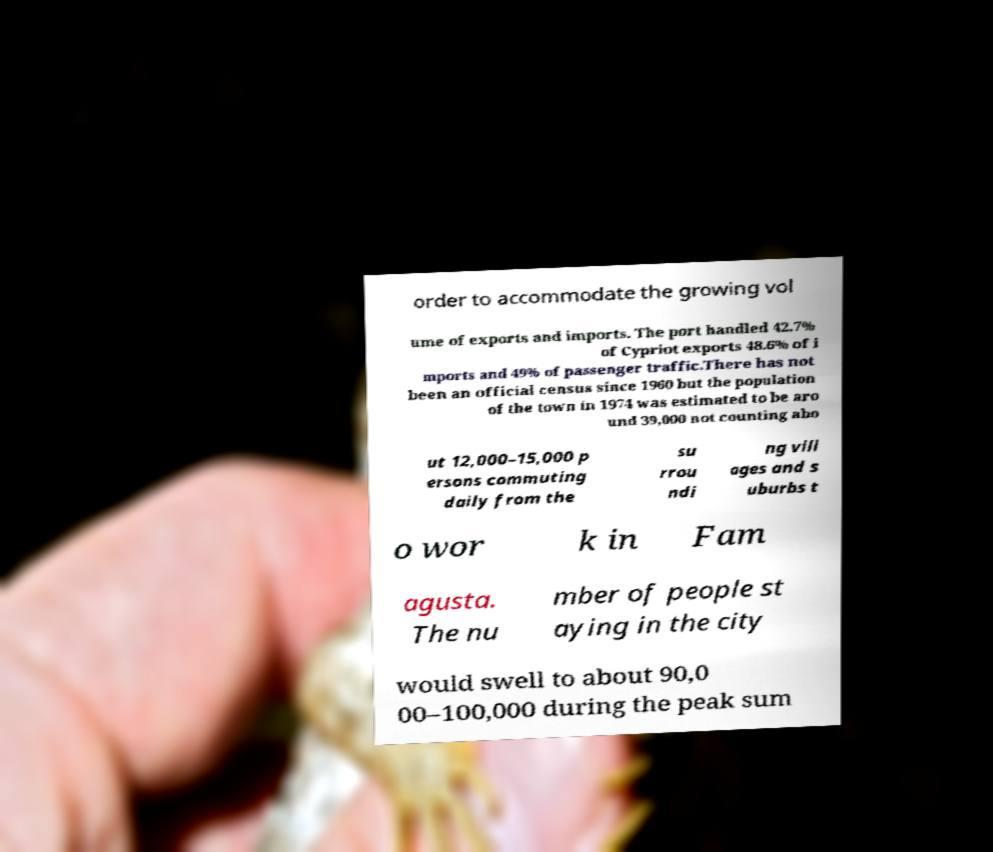I need the written content from this picture converted into text. Can you do that? order to accommodate the growing vol ume of exports and imports. The port handled 42.7% of Cypriot exports 48.6% of i mports and 49% of passenger traffic.There has not been an official census since 1960 but the population of the town in 1974 was estimated to be aro und 39,000 not counting abo ut 12,000–15,000 p ersons commuting daily from the su rrou ndi ng vill ages and s uburbs t o wor k in Fam agusta. The nu mber of people st aying in the city would swell to about 90,0 00–100,000 during the peak sum 